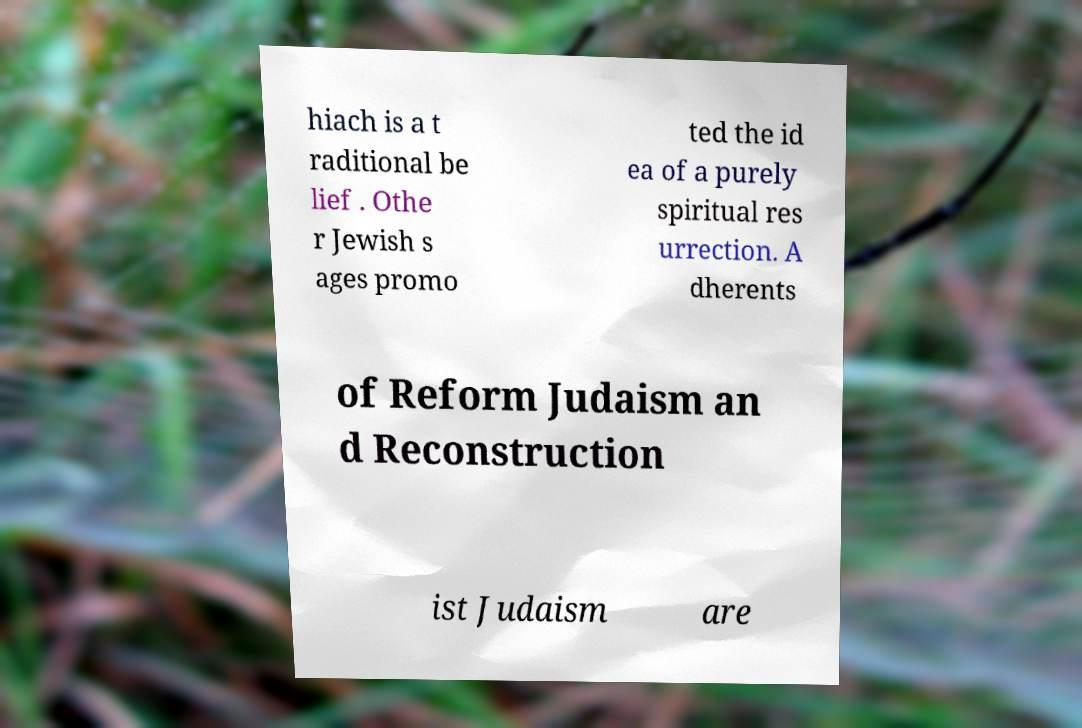There's text embedded in this image that I need extracted. Can you transcribe it verbatim? hiach is a t raditional be lief . Othe r Jewish s ages promo ted the id ea of a purely spiritual res urrection. A dherents of Reform Judaism an d Reconstruction ist Judaism are 